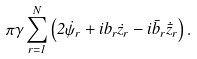<formula> <loc_0><loc_0><loc_500><loc_500>\pi \gamma \sum _ { r = 1 } ^ { N } \left ( 2 \dot { \psi } _ { r } + i b _ { r } \dot { z } _ { r } - i \bar { b } _ { r } \dot { \bar { z } } _ { r } \right ) .</formula> 